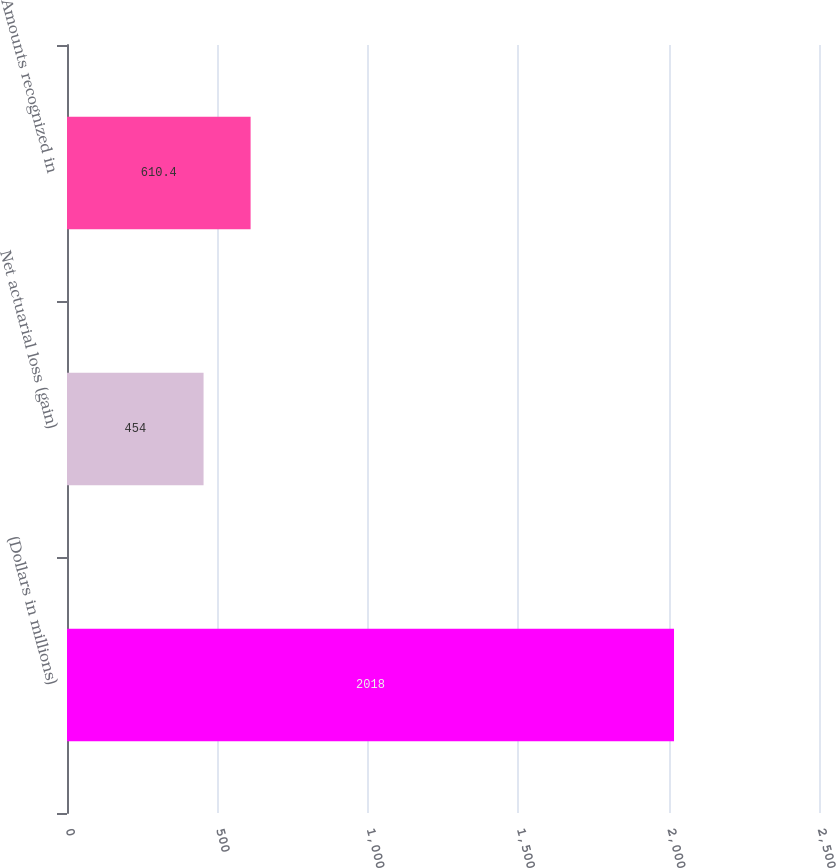<chart> <loc_0><loc_0><loc_500><loc_500><bar_chart><fcel>(Dollars in millions)<fcel>Net actuarial loss (gain)<fcel>Amounts recognized in<nl><fcel>2018<fcel>454<fcel>610.4<nl></chart> 